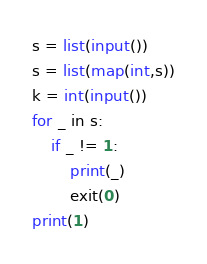Convert code to text. <code><loc_0><loc_0><loc_500><loc_500><_Python_>s = list(input())
s = list(map(int,s))
k = int(input())
for _ in s:
    if _ != 1:
        print(_)
        exit(0)
print(1)</code> 